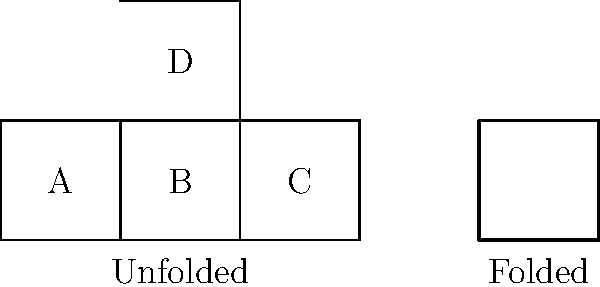As a community volunteer collecting data for spatial intelligence tests, you encounter the following diagram. Which letter represents the face that would be opposite to face A when the shape is folded into a cube? To solve this problem, let's follow these steps:

1. Observe the unfolded shape: It consists of four connected squares labeled A, B, C, and D.

2. Visualize the folding process:
   - Square A remains stationary as the base.
   - Squares B and C fold upwards to form two vertical sides.
   - Square D folds down to form the top of the cube.

3. Analyze the relative positions:
   - Face A is at the bottom of the cube.
   - Face B is adjacent to A and forms a vertical side.
   - Face C is also adjacent to A and forms another vertical side.
   - Face D is connected to B but not directly to A.

4. Determine the opposite face:
   - In a cube, opposite faces are those that don't share any edges.
   - Face D is the only face that doesn't share an edge with A in the folded state.

Therefore, when the shape is folded into a cube, face D will be opposite to face A.
Answer: D 